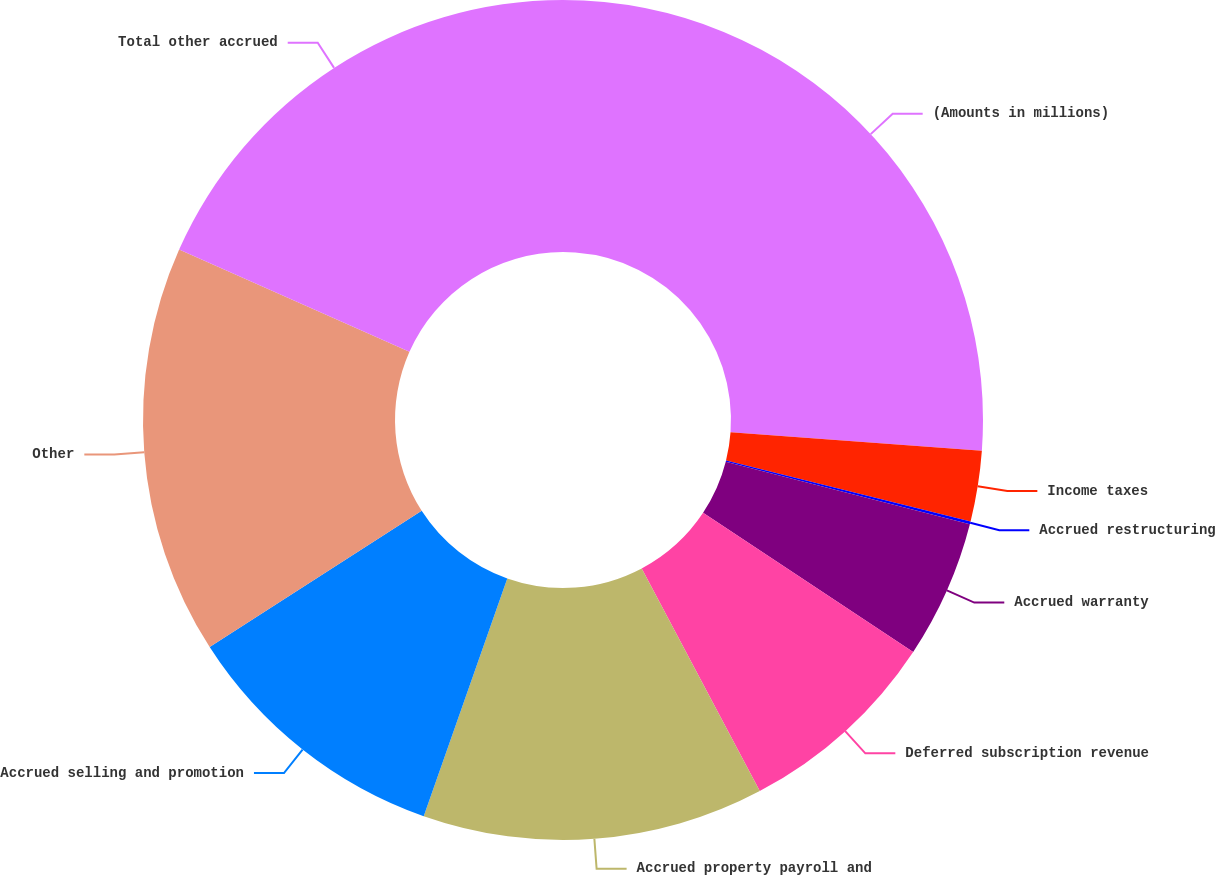Convert chart. <chart><loc_0><loc_0><loc_500><loc_500><pie_chart><fcel>(Amounts in millions)<fcel>Income taxes<fcel>Accrued restructuring<fcel>Accrued warranty<fcel>Deferred subscription revenue<fcel>Accrued property payroll and<fcel>Accrued selling and promotion<fcel>Other<fcel>Total other accrued<nl><fcel>26.17%<fcel>2.71%<fcel>0.11%<fcel>5.32%<fcel>7.93%<fcel>13.14%<fcel>10.53%<fcel>15.74%<fcel>18.35%<nl></chart> 